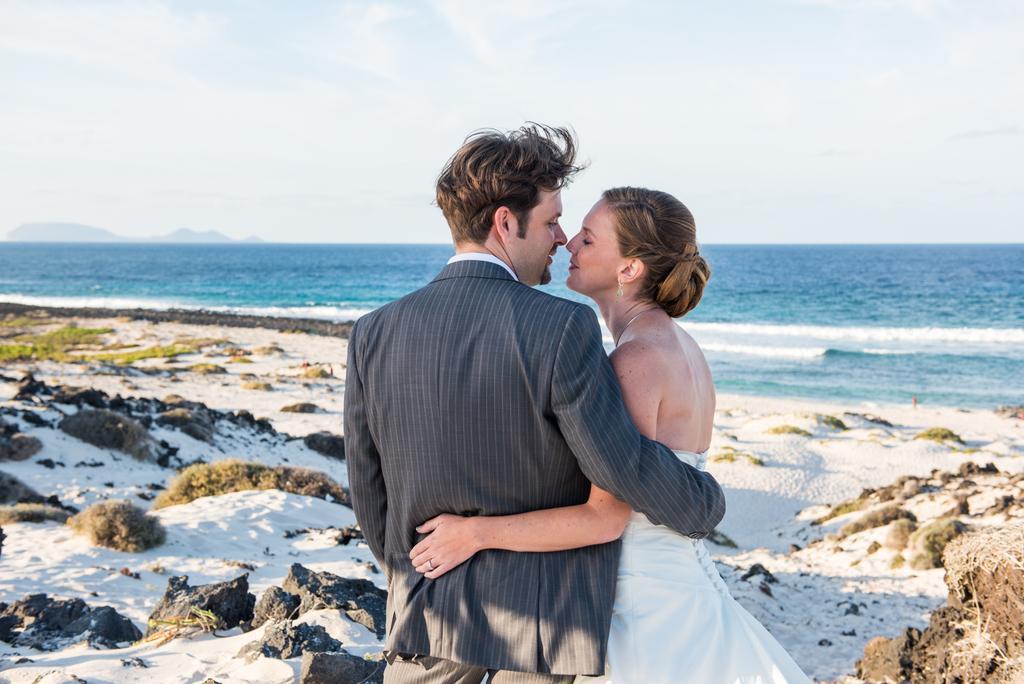Describe this image in one or two sentences. In this image, we can see a woman in white dress and man in a suit are hugging each other. Background we can see the sea, stones, sand, grass. Top of the image, there is a sky. 